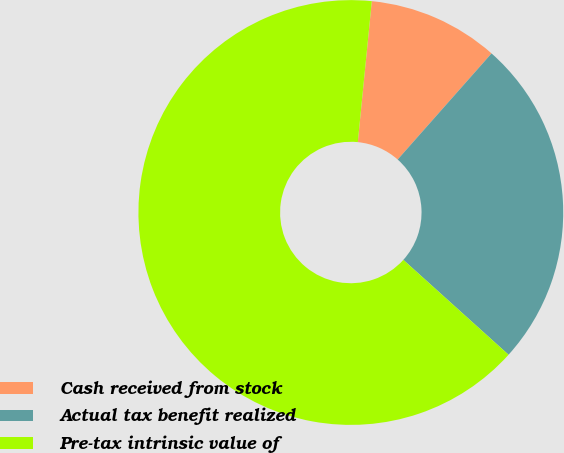<chart> <loc_0><loc_0><loc_500><loc_500><pie_chart><fcel>Cash received from stock<fcel>Actual tax benefit realized<fcel>Pre-tax intrinsic value of<nl><fcel>9.95%<fcel>25.15%<fcel>64.89%<nl></chart> 